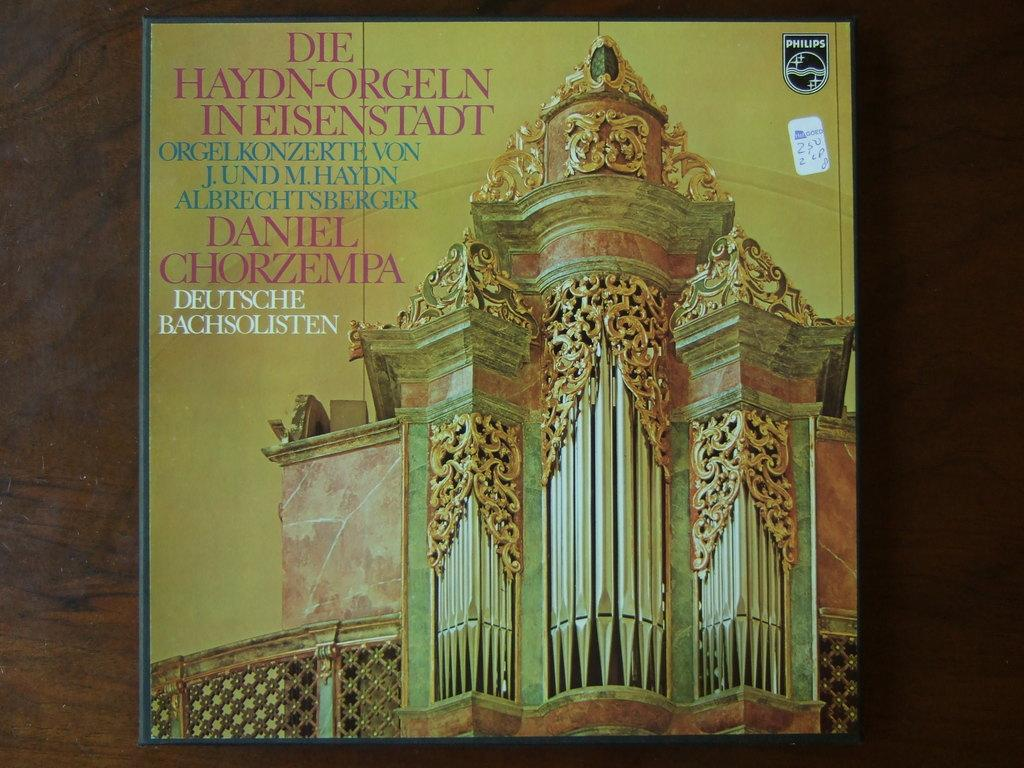What is present in the image that contains both text and an image? There is a poster in the image that contains text and an image. Can you describe the content of the poster? The poster contains text and an image, but the specific content cannot be determined from the provided facts. How much money is being rolled up in the image? There is no mention of money or rolling in the image; the facts only mention a poster with text and an image. 